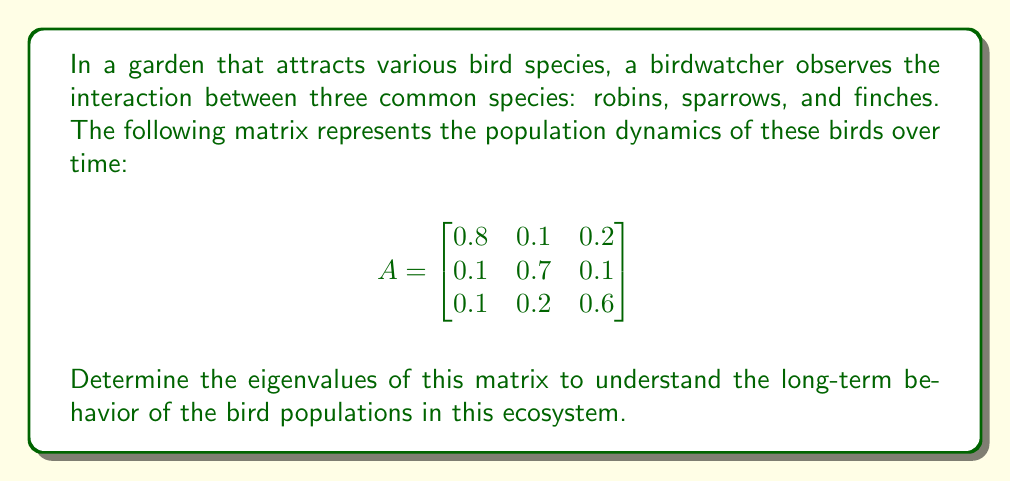Can you solve this math problem? To find the eigenvalues of matrix A, we need to solve the characteristic equation:

1) First, we set up the equation $det(A - \lambda I) = 0$, where $I$ is the 3x3 identity matrix:

   $$det\begin{pmatrix}
   0.8-\lambda & 0.1 & 0.2 \\
   0.1 & 0.7-\lambda & 0.1 \\
   0.1 & 0.2 & 0.6-\lambda
   \end{pmatrix} = 0$$

2) Expand the determinant:
   $$(0.8-\lambda)[(0.7-\lambda)(0.6-\lambda) - 0.02] - 0.1[0.1(0.6-\lambda) - 0.02] + 0.2[0.1(0.7-\lambda) - 0.01] = 0$$

3) Simplify:
   $$(0.8-\lambda)(0.42-1.3\lambda+\lambda^2) - 0.1(0.06-0.1\lambda) + 0.2(0.07-0.1\lambda) = 0$$

4) Expand further:
   $$0.336 - 1.04\lambda + 0.8\lambda^2 - 0.42\lambda + 1.3\lambda^2 - \lambda^3 - 0.006 + 0.01\lambda + 0.014 - 0.02\lambda = 0$$

5) Collect like terms:
   $$-\lambda^3 + 2.1\lambda^2 - 1.47\lambda + 0.344 = 0$$

6) This is a cubic equation. We can solve it using the cubic formula or numerical methods. The solutions to this equation are the eigenvalues.

Using a numerical solver, we find the eigenvalues are approximately:

$\lambda_1 \approx 1$
$\lambda_2 \approx 0.6$
$\lambda_3 \approx 0.5$
Answer: $\lambda_1 \approx 1, \lambda_2 \approx 0.6, \lambda_3 \approx 0.5$ 